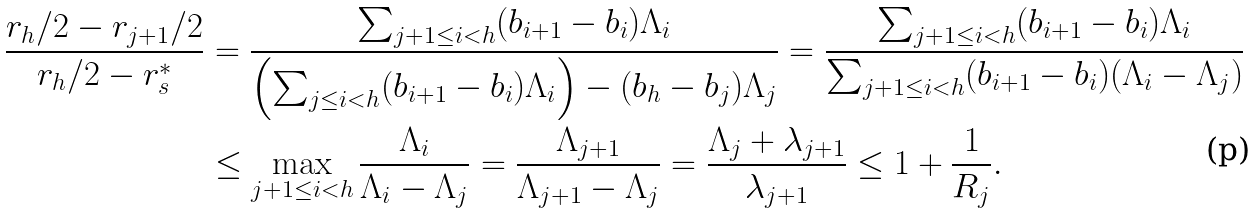<formula> <loc_0><loc_0><loc_500><loc_500>\frac { r _ { h } / 2 - r _ { j + 1 } / 2 } { r _ { h } / 2 - r ^ { * } _ { s } } & = \frac { \sum _ { j + 1 \leq i < h } ( b _ { i + 1 } - b _ { i } ) \Lambda _ { i } } { \left ( \sum _ { j \leq i < h } ( b _ { i + 1 } - b _ { i } ) \Lambda _ { i } \right ) - ( b _ { h } - b _ { j } ) \Lambda _ { j } } = \frac { \sum _ { j + 1 \leq i < h } ( b _ { i + 1 } - b _ { i } ) \Lambda _ { i } } { \sum _ { j + 1 \leq i < h } ( b _ { i + 1 } - b _ { i } ) ( \Lambda _ { i } - \Lambda _ { j } ) } \\ & \leq \max _ { j + 1 \leq i < h } \frac { \Lambda _ { i } } { \Lambda _ { i } - \Lambda _ { j } } = \frac { \Lambda _ { j + 1 } } { \Lambda _ { j + 1 } - \Lambda _ { j } } = \frac { \Lambda _ { j } + \lambda _ { j + 1 } } { \lambda _ { j + 1 } } \leq 1 + \frac { 1 } { R _ { j } } .</formula> 